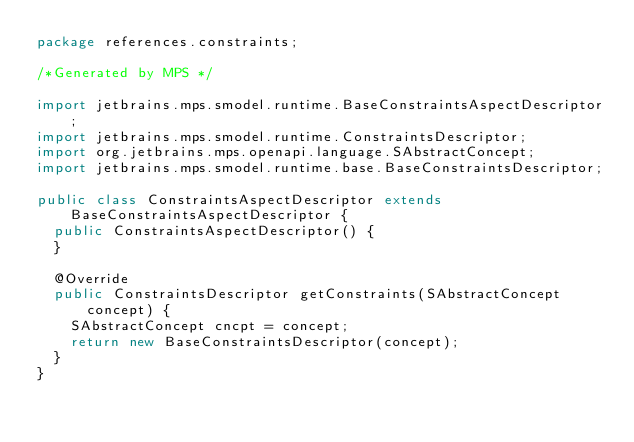Convert code to text. <code><loc_0><loc_0><loc_500><loc_500><_Java_>package references.constraints;

/*Generated by MPS */

import jetbrains.mps.smodel.runtime.BaseConstraintsAspectDescriptor;
import jetbrains.mps.smodel.runtime.ConstraintsDescriptor;
import org.jetbrains.mps.openapi.language.SAbstractConcept;
import jetbrains.mps.smodel.runtime.base.BaseConstraintsDescriptor;

public class ConstraintsAspectDescriptor extends BaseConstraintsAspectDescriptor {
  public ConstraintsAspectDescriptor() {
  }

  @Override
  public ConstraintsDescriptor getConstraints(SAbstractConcept concept) {
    SAbstractConcept cncpt = concept;
    return new BaseConstraintsDescriptor(concept);
  }
}
</code> 